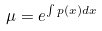Convert formula to latex. <formula><loc_0><loc_0><loc_500><loc_500>\mu = e ^ { \int p ( x ) d x }</formula> 